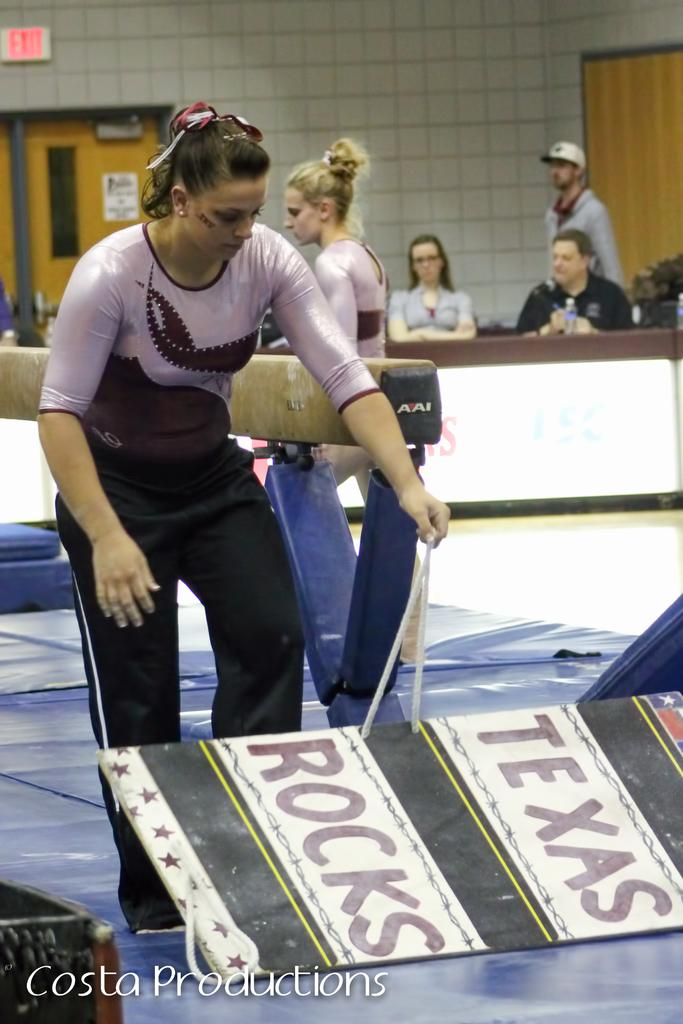What is the main subject of the image? There is a lady standing in the image. What is the lady holding in the image? The lady is holding something. Can you describe the people behind the lady? There are other people behind the lady. What type of copper object can be seen being smashed by the lady in the image? There is no copper object or any object being smashed in the image. The lady is simply holding something, but the facts do not specify what it is. 